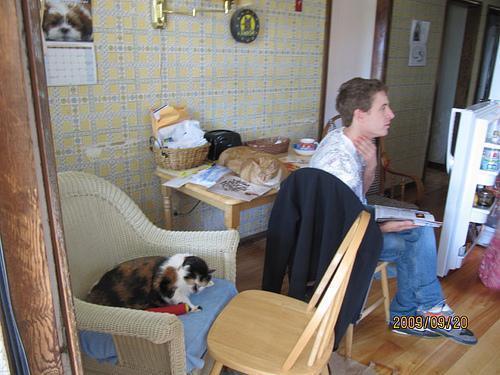How many cats are in the picture?
Give a very brief answer. 1. How many cats are in the picture?
Give a very brief answer. 2. How many chairs are in the photo?
Give a very brief answer. 3. How many cats are there?
Give a very brief answer. 2. How many horses are there?
Give a very brief answer. 0. 